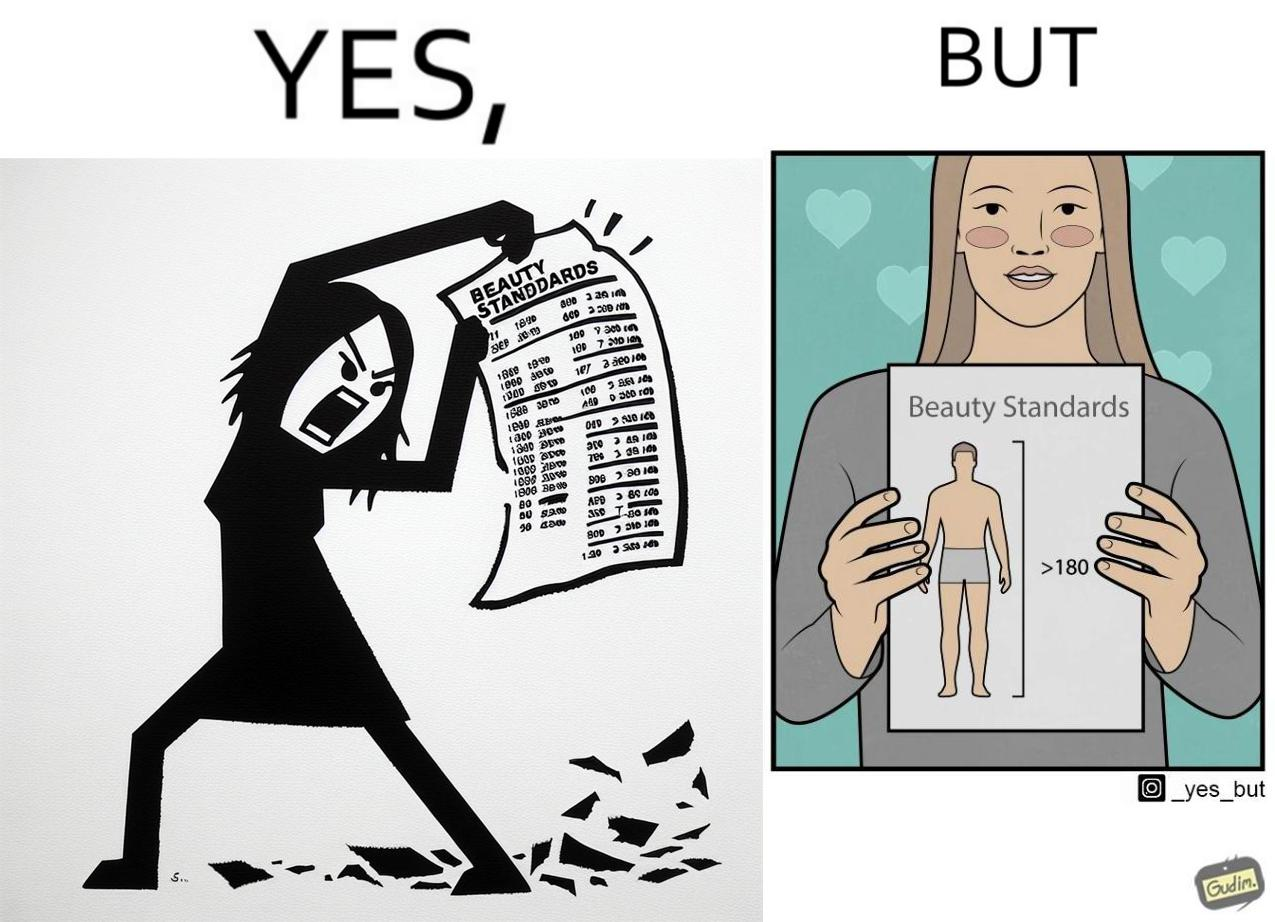Describe the content of this image. The image is ironic because the woman that is angry about having constraints set on the body parts of a woman to be considered beautiful is the same person who is happily presenting contraints on the height of a man to be considered beautiful. 